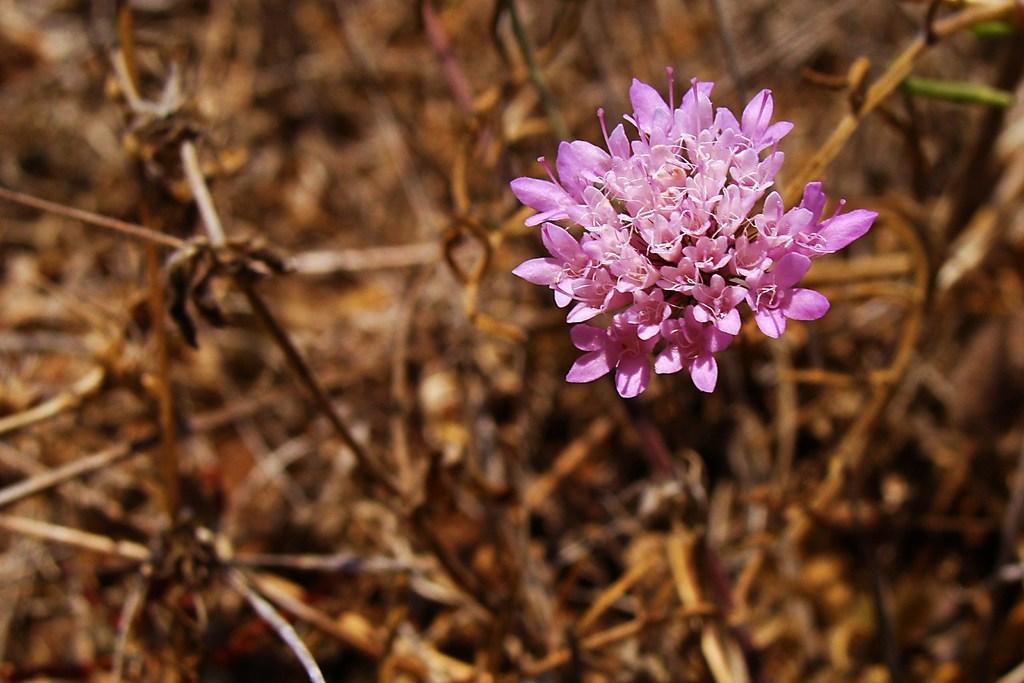Can you describe this image briefly? There are pink color flowers. In the background it is blurred and brown in color. 